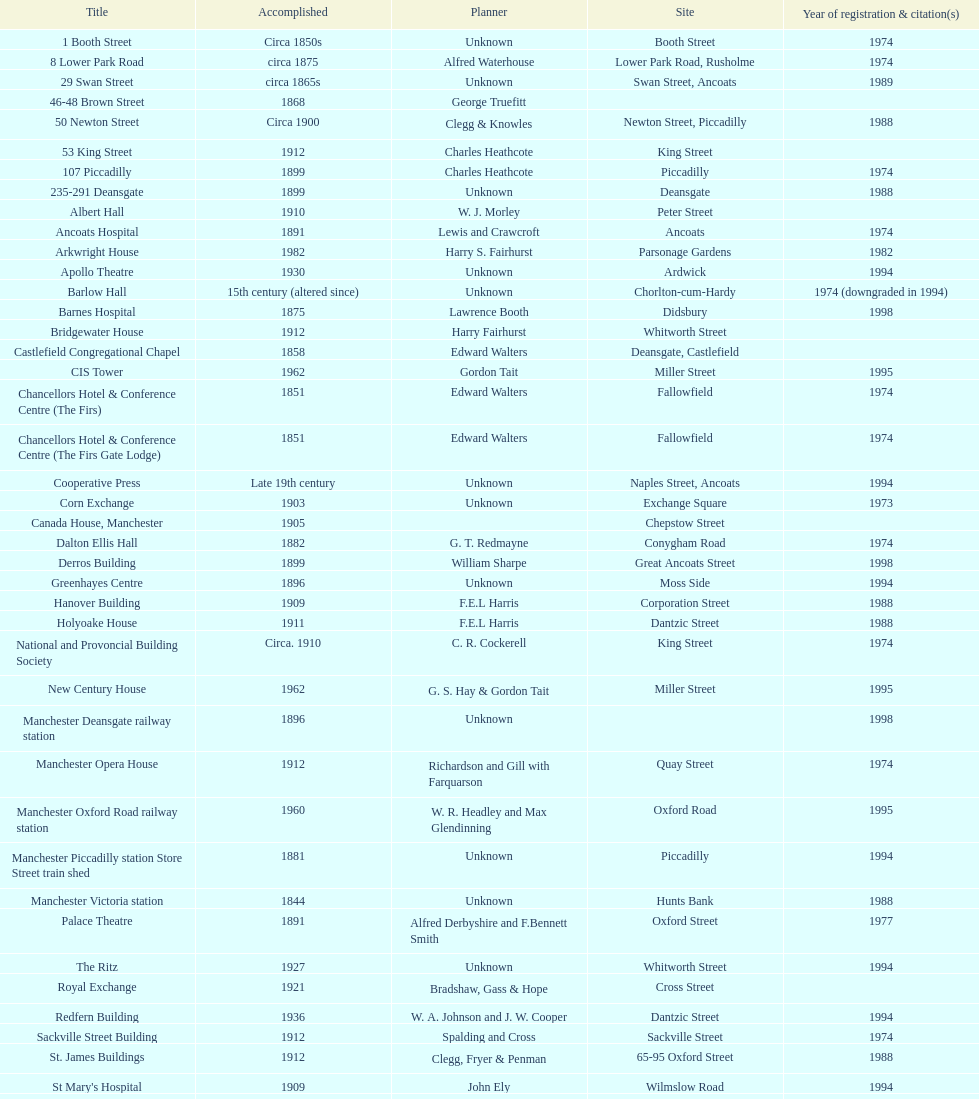What is the gap, in terms of years, between the completion of 53 king street and castlefield congregational chapel? 54 years. 